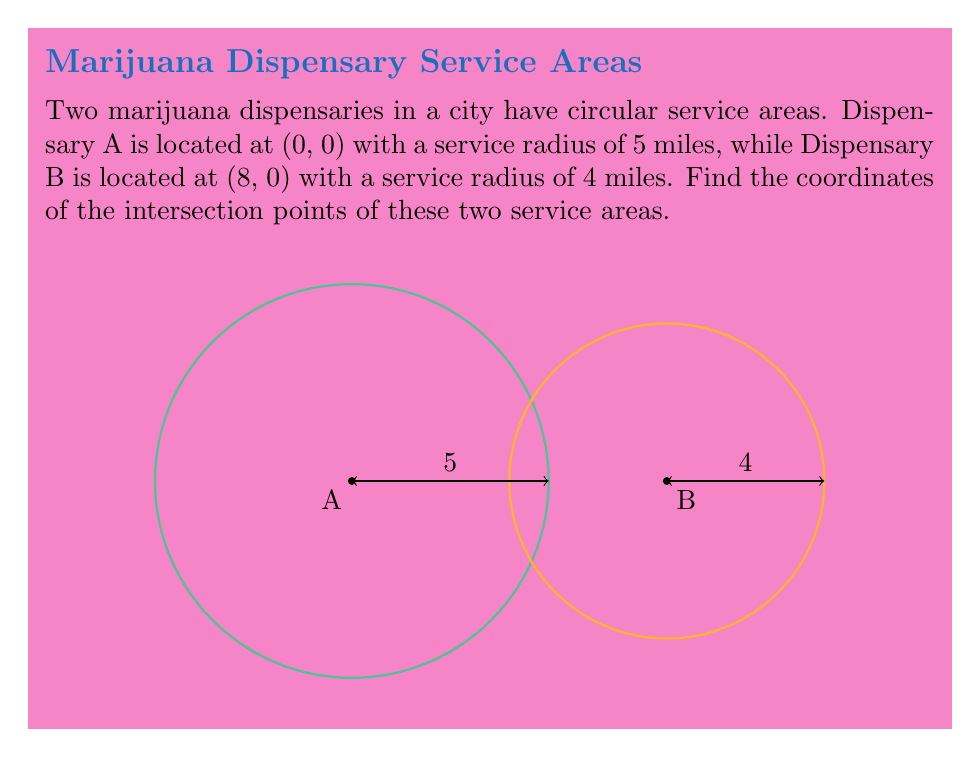Solve this math problem. To find the intersection points of two circles, we can follow these steps:

1) The equations of the two circles are:

   Circle A: $x^2 + y^2 = 25$
   Circle B: $(x-8)^2 + y^2 = 16$

2) Subtract the second equation from the first:

   $x^2 + y^2 - ((x-8)^2 + y^2) = 25 - 16$
   $x^2 - (x^2 - 16x + 64) = 9$
   $16x - 64 = 9$
   $16x = 73$
   $x = \frac{73}{16} = 4.5625$

3) Substitute this x-value into the equation of Circle A:

   $(4.5625)^2 + y^2 = 25$
   $20.8164 + y^2 = 25$
   $y^2 = 4.1836$
   $y = \pm \sqrt{4.1836} = \pm 2.0454$

4) Therefore, the intersection points are:

   $(4.5625, 2.0454)$ and $(4.5625, -2.0454)$

These points represent where the service areas of the two dispensaries overlap, which could be crucial information for a marijuana industry lobbyist advocating for efficient coverage and fair competition.
Answer: $(4.5625, 2.0454)$ and $(4.5625, -2.0454)$ 